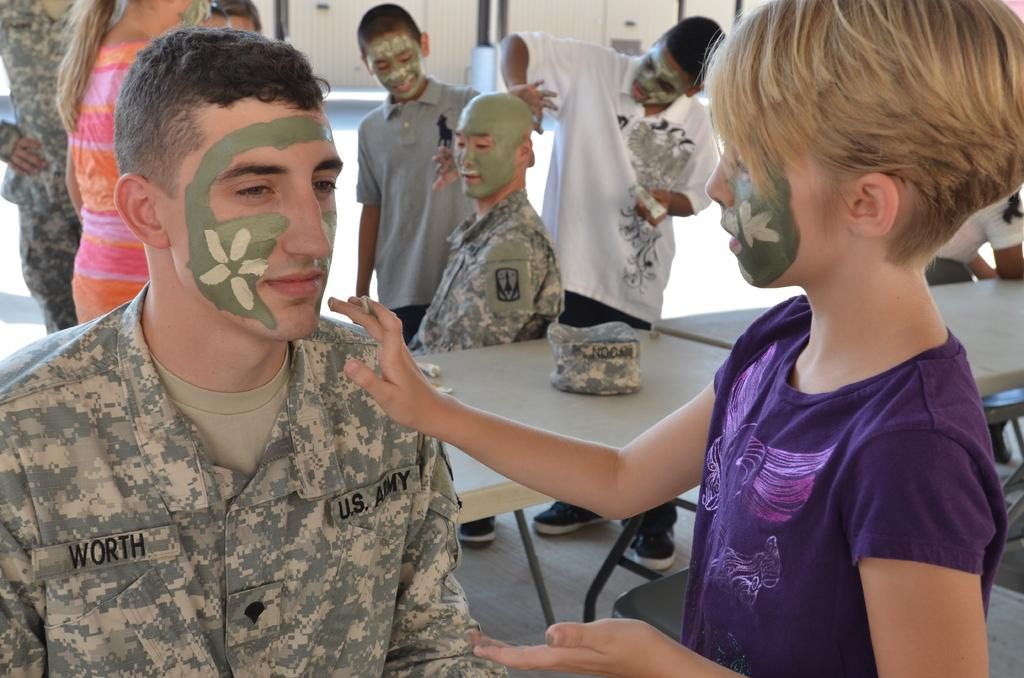Who or what can be seen in the image? There are people in the image. What type of furniture is present in the image? There are tables in the image. Can you describe a specific table in the image? There is a table with objects in the image. What can be seen beneath the people and tables in the image? The ground is visible in the image. What architectural feature can be seen in the image? There is a wall in the image. What vertical structure is present in the image? There is a pole in the image. What type of instrument is being played by the people in the image? There is no instrument being played by the people in the image. What is the back of the image made of? The back of the image is not visible or relevant, as the image is a flat representation. 